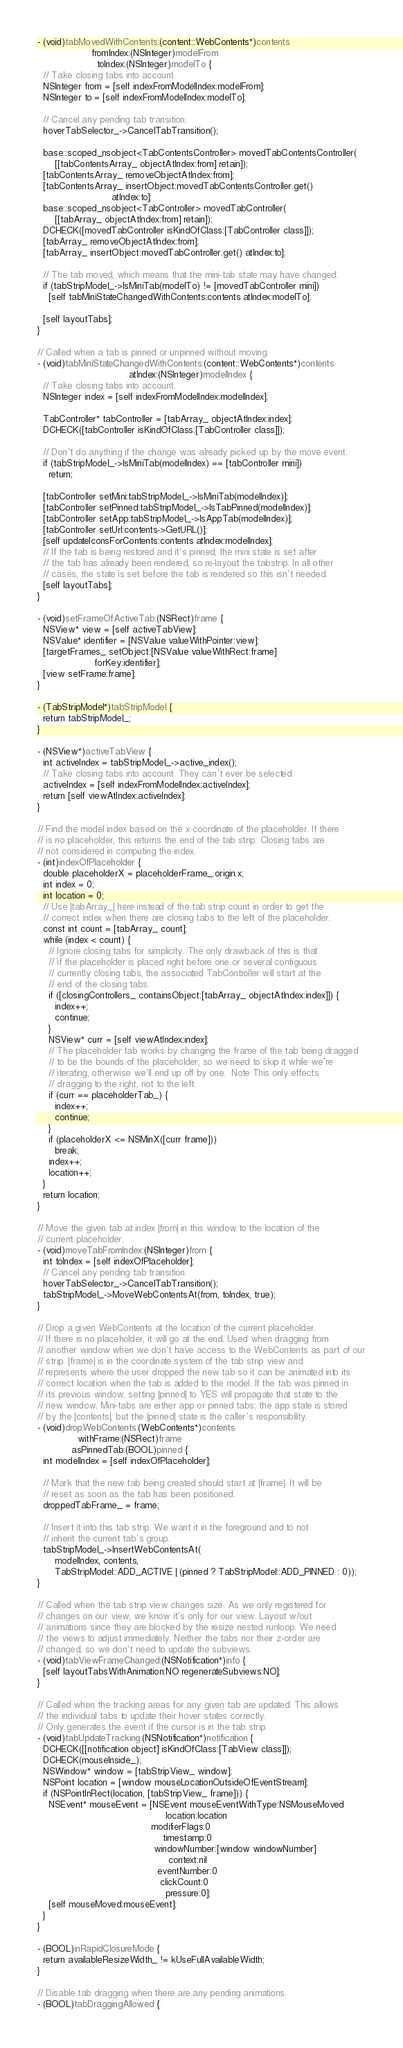Convert code to text. <code><loc_0><loc_0><loc_500><loc_500><_ObjectiveC_>- (void)tabMovedWithContents:(content::WebContents*)contents
                   fromIndex:(NSInteger)modelFrom
                     toIndex:(NSInteger)modelTo {
  // Take closing tabs into account.
  NSInteger from = [self indexFromModelIndex:modelFrom];
  NSInteger to = [self indexFromModelIndex:modelTo];

  // Cancel any pending tab transition.
  hoverTabSelector_->CancelTabTransition();

  base::scoped_nsobject<TabContentsController> movedTabContentsController(
      [[tabContentsArray_ objectAtIndex:from] retain]);
  [tabContentsArray_ removeObjectAtIndex:from];
  [tabContentsArray_ insertObject:movedTabContentsController.get()
                          atIndex:to];
  base::scoped_nsobject<TabController> movedTabController(
      [[tabArray_ objectAtIndex:from] retain]);
  DCHECK([movedTabController isKindOfClass:[TabController class]]);
  [tabArray_ removeObjectAtIndex:from];
  [tabArray_ insertObject:movedTabController.get() atIndex:to];

  // The tab moved, which means that the mini-tab state may have changed.
  if (tabStripModel_->IsMiniTab(modelTo) != [movedTabController mini])
    [self tabMiniStateChangedWithContents:contents atIndex:modelTo];

  [self layoutTabs];
}

// Called when a tab is pinned or unpinned without moving.
- (void)tabMiniStateChangedWithContents:(content::WebContents*)contents
                                atIndex:(NSInteger)modelIndex {
  // Take closing tabs into account.
  NSInteger index = [self indexFromModelIndex:modelIndex];

  TabController* tabController = [tabArray_ objectAtIndex:index];
  DCHECK([tabController isKindOfClass:[TabController class]]);

  // Don't do anything if the change was already picked up by the move event.
  if (tabStripModel_->IsMiniTab(modelIndex) == [tabController mini])
    return;

  [tabController setMini:tabStripModel_->IsMiniTab(modelIndex)];
  [tabController setPinned:tabStripModel_->IsTabPinned(modelIndex)];
  [tabController setApp:tabStripModel_->IsAppTab(modelIndex)];
  [tabController setUrl:contents->GetURL()];
  [self updateIconsForContents:contents atIndex:modelIndex];
  // If the tab is being restored and it's pinned, the mini state is set after
  // the tab has already been rendered, so re-layout the tabstrip. In all other
  // cases, the state is set before the tab is rendered so this isn't needed.
  [self layoutTabs];
}

- (void)setFrameOfActiveTab:(NSRect)frame {
  NSView* view = [self activeTabView];
  NSValue* identifier = [NSValue valueWithPointer:view];
  [targetFrames_ setObject:[NSValue valueWithRect:frame]
                    forKey:identifier];
  [view setFrame:frame];
}

- (TabStripModel*)tabStripModel {
  return tabStripModel_;
}

- (NSView*)activeTabView {
  int activeIndex = tabStripModel_->active_index();
  // Take closing tabs into account. They can't ever be selected.
  activeIndex = [self indexFromModelIndex:activeIndex];
  return [self viewAtIndex:activeIndex];
}

// Find the model index based on the x coordinate of the placeholder. If there
// is no placeholder, this returns the end of the tab strip. Closing tabs are
// not considered in computing the index.
- (int)indexOfPlaceholder {
  double placeholderX = placeholderFrame_.origin.x;
  int index = 0;
  int location = 0;
  // Use |tabArray_| here instead of the tab strip count in order to get the
  // correct index when there are closing tabs to the left of the placeholder.
  const int count = [tabArray_ count];
  while (index < count) {
    // Ignore closing tabs for simplicity. The only drawback of this is that
    // if the placeholder is placed right before one or several contiguous
    // currently closing tabs, the associated TabController will start at the
    // end of the closing tabs.
    if ([closingControllers_ containsObject:[tabArray_ objectAtIndex:index]]) {
      index++;
      continue;
    }
    NSView* curr = [self viewAtIndex:index];
    // The placeholder tab works by changing the frame of the tab being dragged
    // to be the bounds of the placeholder, so we need to skip it while we're
    // iterating, otherwise we'll end up off by one.  Note This only effects
    // dragging to the right, not to the left.
    if (curr == placeholderTab_) {
      index++;
      continue;
    }
    if (placeholderX <= NSMinX([curr frame]))
      break;
    index++;
    location++;
  }
  return location;
}

// Move the given tab at index |from| in this window to the location of the
// current placeholder.
- (void)moveTabFromIndex:(NSInteger)from {
  int toIndex = [self indexOfPlaceholder];
  // Cancel any pending tab transition.
  hoverTabSelector_->CancelTabTransition();
  tabStripModel_->MoveWebContentsAt(from, toIndex, true);
}

// Drop a given WebContents at the location of the current placeholder.
// If there is no placeholder, it will go at the end. Used when dragging from
// another window when we don't have access to the WebContents as part of our
// strip. |frame| is in the coordinate system of the tab strip view and
// represents where the user dropped the new tab so it can be animated into its
// correct location when the tab is added to the model. If the tab was pinned in
// its previous window, setting |pinned| to YES will propagate that state to the
// new window. Mini-tabs are either app or pinned tabs; the app state is stored
// by the |contents|, but the |pinned| state is the caller's responsibility.
- (void)dropWebContents:(WebContents*)contents
              withFrame:(NSRect)frame
            asPinnedTab:(BOOL)pinned {
  int modelIndex = [self indexOfPlaceholder];

  // Mark that the new tab being created should start at |frame|. It will be
  // reset as soon as the tab has been positioned.
  droppedTabFrame_ = frame;

  // Insert it into this tab strip. We want it in the foreground and to not
  // inherit the current tab's group.
  tabStripModel_->InsertWebContentsAt(
      modelIndex, contents,
      TabStripModel::ADD_ACTIVE | (pinned ? TabStripModel::ADD_PINNED : 0));
}

// Called when the tab strip view changes size. As we only registered for
// changes on our view, we know it's only for our view. Layout w/out
// animations since they are blocked by the resize nested runloop. We need
// the views to adjust immediately. Neither the tabs nor their z-order are
// changed, so we don't need to update the subviews.
- (void)tabViewFrameChanged:(NSNotification*)info {
  [self layoutTabsWithAnimation:NO regenerateSubviews:NO];
}

// Called when the tracking areas for any given tab are updated. This allows
// the individual tabs to update their hover states correctly.
// Only generates the event if the cursor is in the tab strip.
- (void)tabUpdateTracking:(NSNotification*)notification {
  DCHECK([[notification object] isKindOfClass:[TabView class]]);
  DCHECK(mouseInside_);
  NSWindow* window = [tabStripView_ window];
  NSPoint location = [window mouseLocationOutsideOfEventStream];
  if (NSPointInRect(location, [tabStripView_ frame])) {
    NSEvent* mouseEvent = [NSEvent mouseEventWithType:NSMouseMoved
                                             location:location
                                        modifierFlags:0
                                            timestamp:0
                                         windowNumber:[window windowNumber]
                                              context:nil
                                          eventNumber:0
                                           clickCount:0
                                             pressure:0];
    [self mouseMoved:mouseEvent];
  }
}

- (BOOL)inRapidClosureMode {
  return availableResizeWidth_ != kUseFullAvailableWidth;
}

// Disable tab dragging when there are any pending animations.
- (BOOL)tabDraggingAllowed {</code> 